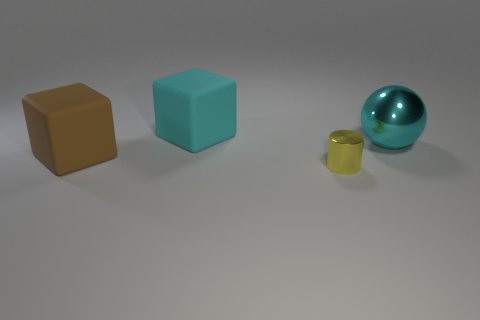Are there any other things that are the same size as the yellow shiny cylinder?
Your answer should be compact. No. What color is the large rubber cube that is behind the rubber block to the left of the rubber cube that is behind the big brown thing?
Keep it short and to the point. Cyan. There is a metallic ball that is the same size as the brown object; what is its color?
Your answer should be very brief. Cyan. The metal object in front of the rubber object to the left of the large cyan thing that is on the left side of the metal cylinder is what shape?
Offer a very short reply. Cylinder. What is the shape of the other object that is the same color as the large metal object?
Give a very brief answer. Cube. How many things are either spheres or large cyan objects right of the cyan matte block?
Your answer should be very brief. 1. Is the size of the rubber block that is on the right side of the brown rubber thing the same as the brown thing?
Keep it short and to the point. Yes. There is a object that is to the right of the yellow cylinder; what is its material?
Keep it short and to the point. Metal. Are there an equal number of cyan balls that are behind the cyan block and cyan blocks behind the big metal sphere?
Your answer should be very brief. No. There is another rubber object that is the same shape as the cyan rubber object; what color is it?
Make the answer very short. Brown. 